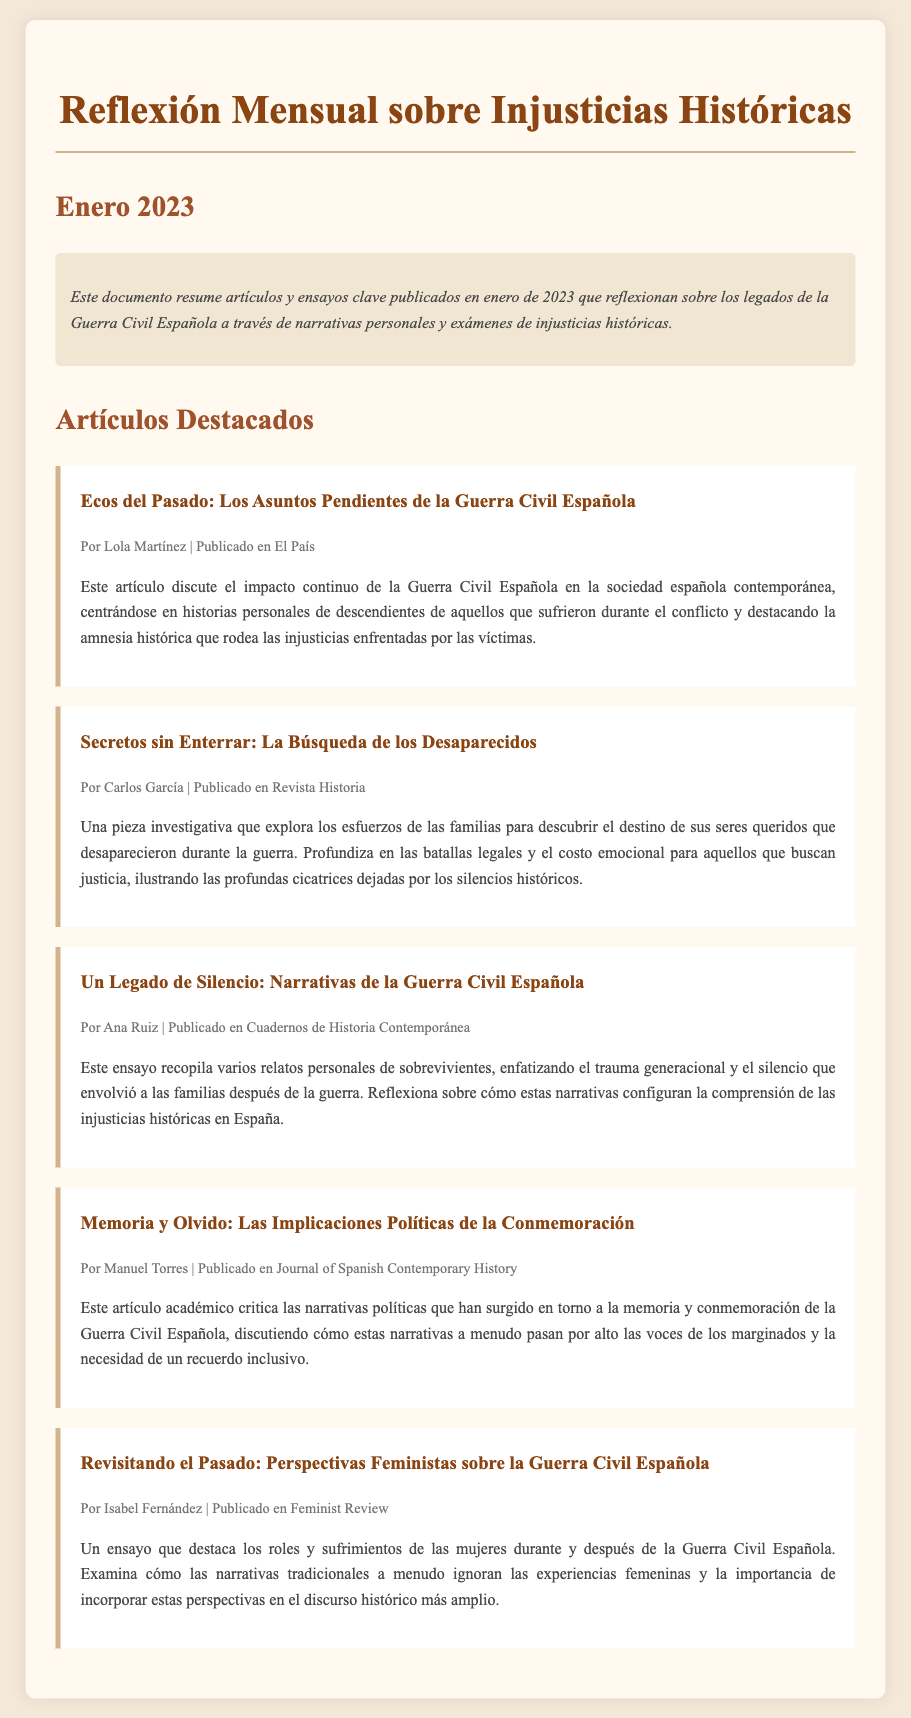¿Qué es el tema central del documento? El documento resume artículos y ensayos que reflexionan sobre los legados de la Guerra Civil Española, enfocándose en narrativas personales y injusticias históricas.
Answer: Legados de la Guerra Civil Española ¿Cuántos artículos destacados se presentan? Se presentan cinco artículos destacados en el documento.
Answer: Cinco ¿Quién es el autor del artículo "Ecos del Pasado: Los Asuntos Pendientes de la Guerra Civil Española"? El artículo "Ecos del Pasado: Los Asuntos Pendientes de la Guerra Civil Española" es escrito por Lola Martínez.
Answer: Lola Martínez ¿Qué revista publicó el artículo de Carlos García? El artículo de Carlos García fue publicado en "Revista Historia".
Answer: Revista Historia ¿Cuál es el enfoque principal del ensayo de Isabel Fernández? El enfoque principal del ensayo de Isabel Fernández es sobre los roles y sufrimientos de las mujeres durante y después de la Guerra Civil Española.
Answer: Roles y sufrimientos de las mujeres ¿Qué crítica se presenta en el artículo de Manuel Torres? El artículo de Manuel Torres critica las narrativas políticas sobre la memoria y conmemoración de la Guerra Civil Española, destacando la omisión de voces marginadas.
Answer: Narrativas políticas sobre la memoria ¿Qué tipo de documento es este? Este documento es un resumen de artículos y ensayos.
Answer: Resumen ¿En qué mes se centra la reflexión de este documento? La reflexión de este documento se centra en el mes de enero.
Answer: Enero 